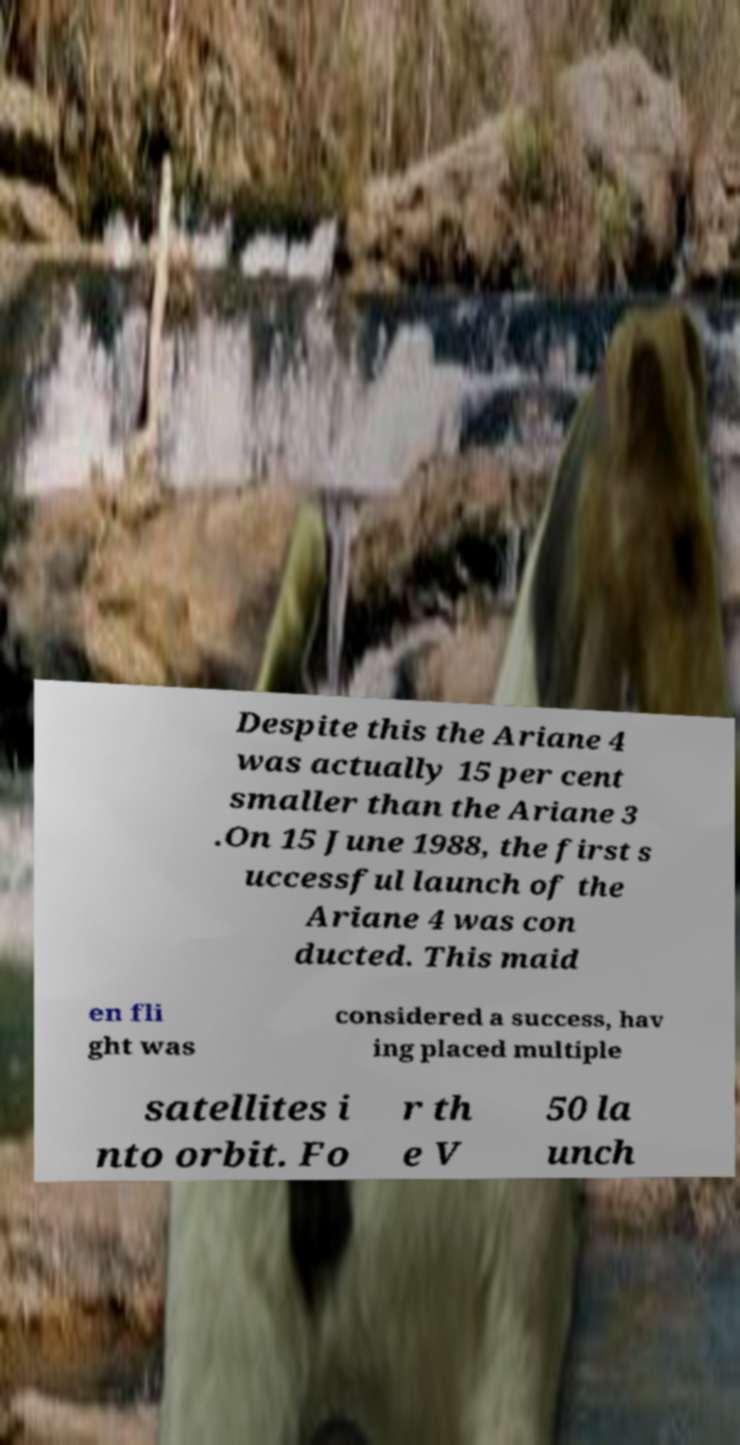I need the written content from this picture converted into text. Can you do that? Despite this the Ariane 4 was actually 15 per cent smaller than the Ariane 3 .On 15 June 1988, the first s uccessful launch of the Ariane 4 was con ducted. This maid en fli ght was considered a success, hav ing placed multiple satellites i nto orbit. Fo r th e V 50 la unch 